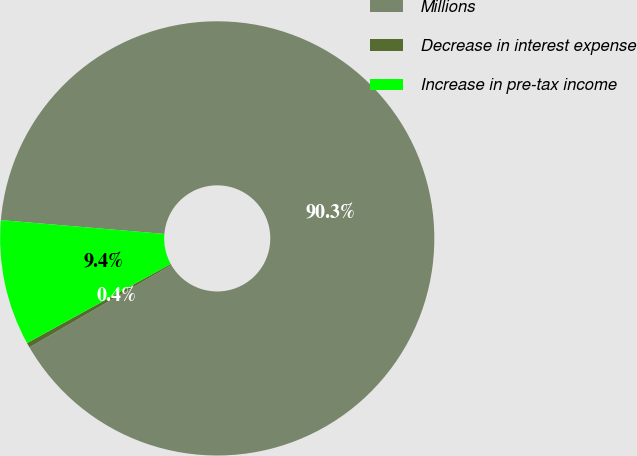<chart> <loc_0><loc_0><loc_500><loc_500><pie_chart><fcel>Millions<fcel>Decrease in interest expense<fcel>Increase in pre-tax income<nl><fcel>90.29%<fcel>0.36%<fcel>9.35%<nl></chart> 